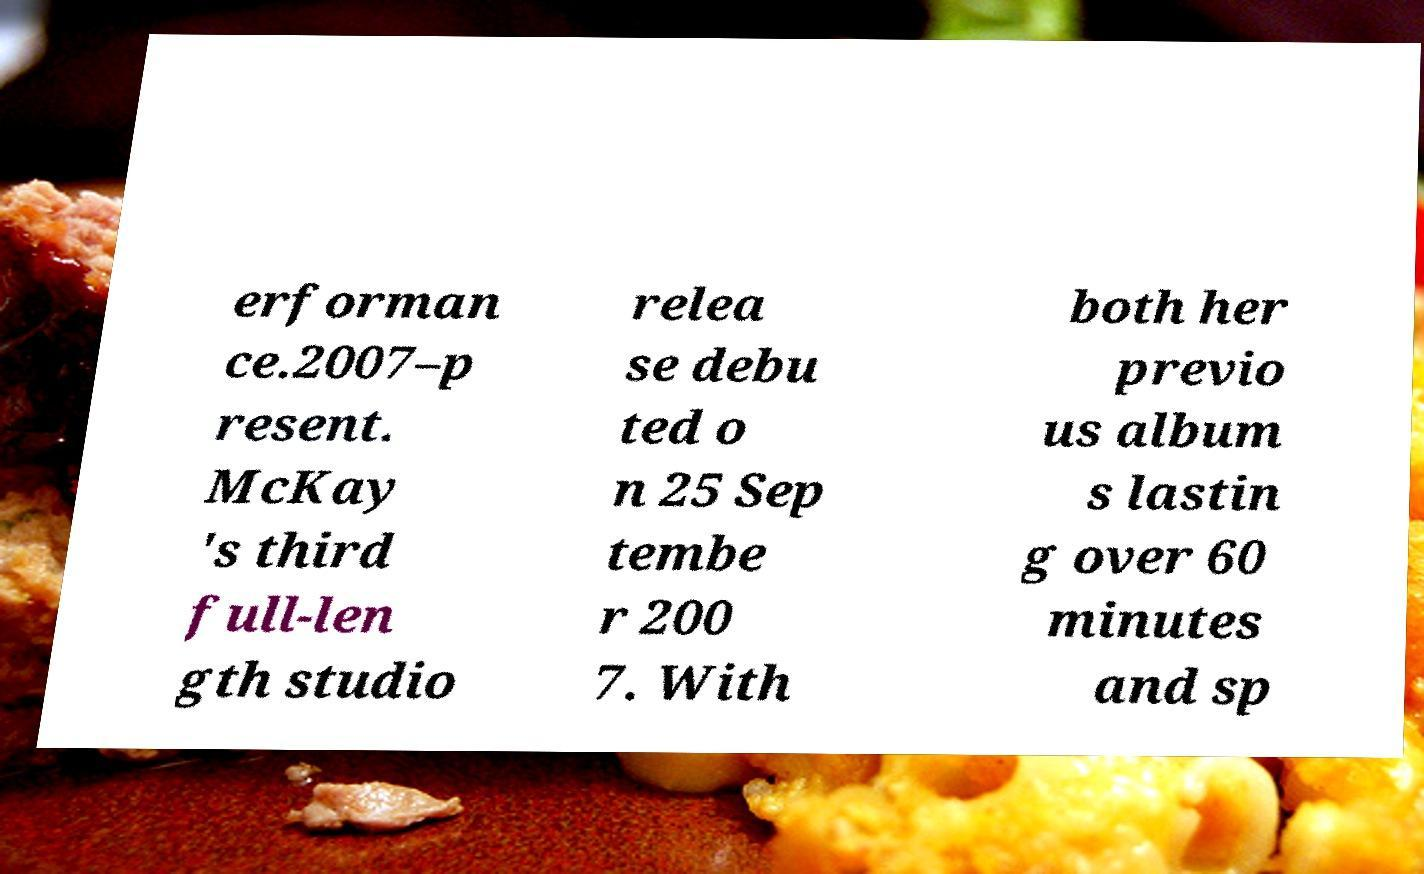Could you extract and type out the text from this image? erforman ce.2007–p resent. McKay 's third full-len gth studio relea se debu ted o n 25 Sep tembe r 200 7. With both her previo us album s lastin g over 60 minutes and sp 